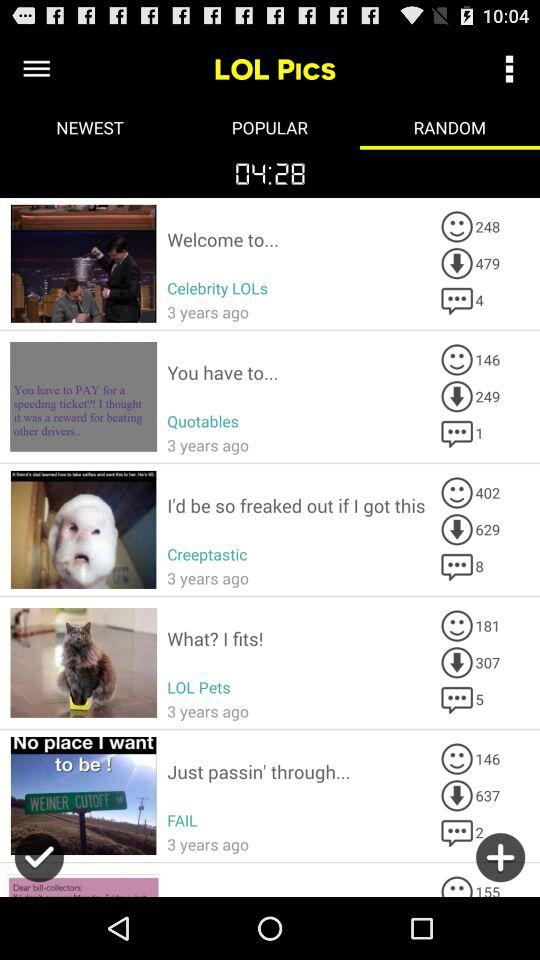What is the selected tab? The selected tab is "RANDOM". 